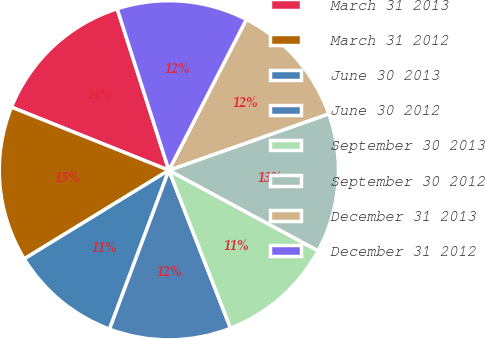Convert chart. <chart><loc_0><loc_0><loc_500><loc_500><pie_chart><fcel>March 31 2013<fcel>March 31 2012<fcel>June 30 2013<fcel>June 30 2012<fcel>September 30 2013<fcel>September 30 2012<fcel>December 31 2013<fcel>December 31 2012<nl><fcel>14.0%<fcel>14.82%<fcel>10.56%<fcel>11.62%<fcel>11.2%<fcel>13.27%<fcel>12.05%<fcel>12.48%<nl></chart> 